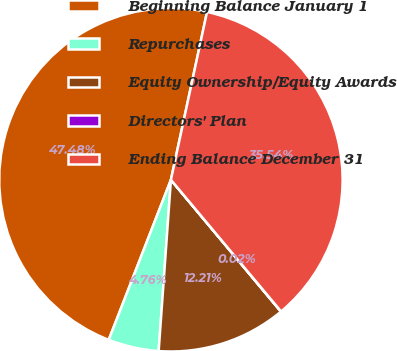Convert chart to OTSL. <chart><loc_0><loc_0><loc_500><loc_500><pie_chart><fcel>Beginning Balance January 1<fcel>Repurchases<fcel>Equity Ownership/Equity Awards<fcel>Directors' Plan<fcel>Ending Balance December 31<nl><fcel>47.48%<fcel>4.76%<fcel>12.21%<fcel>0.02%<fcel>35.54%<nl></chart> 